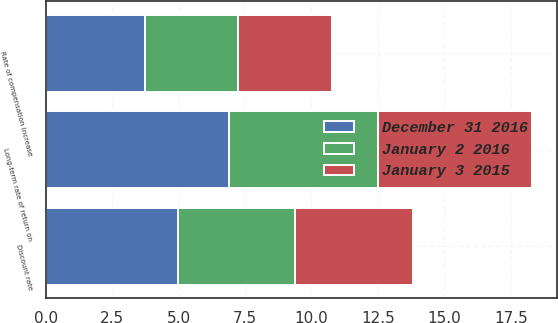Convert chart to OTSL. <chart><loc_0><loc_0><loc_500><loc_500><stacked_bar_chart><ecel><fcel>Discount rate<fcel>Long-term rate of return on<fcel>Rate of compensation increase<nl><fcel>January 3 2015<fcel>4.43<fcel>5.8<fcel>3.51<nl><fcel>January 2 2016<fcel>4.43<fcel>5.61<fcel>3.51<nl><fcel>December 31 2016<fcel>4.96<fcel>6.9<fcel>3.74<nl></chart> 